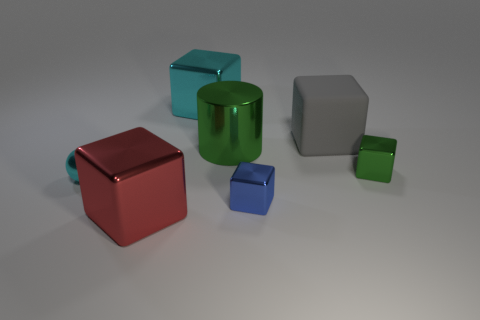Subtract all gray cubes. How many cubes are left? 4 Subtract 2 blocks. How many blocks are left? 3 Subtract all large red blocks. How many blocks are left? 4 Subtract all cyan blocks. Subtract all brown balls. How many blocks are left? 4 Add 3 large gray matte blocks. How many objects exist? 10 Subtract all cylinders. How many objects are left? 6 Subtract all gray objects. Subtract all yellow rubber spheres. How many objects are left? 6 Add 1 tiny objects. How many tiny objects are left? 4 Add 1 red shiny spheres. How many red shiny spheres exist? 1 Subtract 0 gray cylinders. How many objects are left? 7 